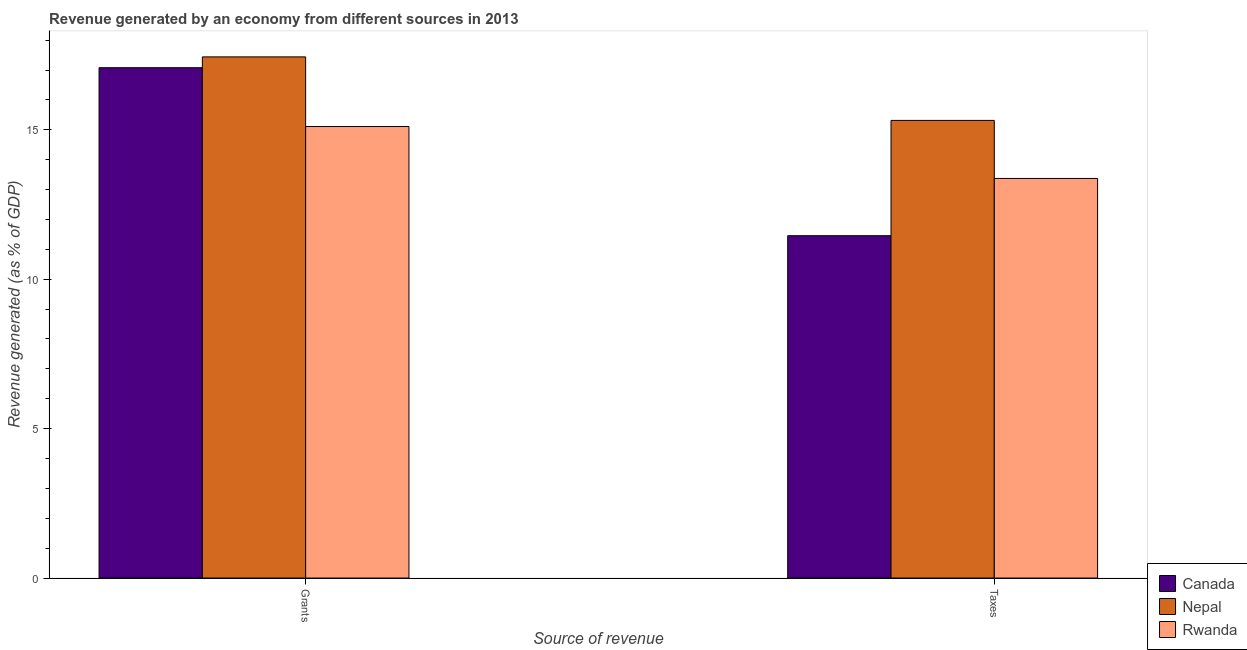How many groups of bars are there?
Ensure brevity in your answer.  2. Are the number of bars on each tick of the X-axis equal?
Keep it short and to the point. Yes. How many bars are there on the 2nd tick from the right?
Make the answer very short. 3. What is the label of the 2nd group of bars from the left?
Provide a short and direct response. Taxes. What is the revenue generated by taxes in Nepal?
Provide a succinct answer. 15.31. Across all countries, what is the maximum revenue generated by taxes?
Your response must be concise. 15.31. Across all countries, what is the minimum revenue generated by grants?
Give a very brief answer. 15.11. In which country was the revenue generated by taxes maximum?
Provide a succinct answer. Nepal. In which country was the revenue generated by grants minimum?
Make the answer very short. Rwanda. What is the total revenue generated by grants in the graph?
Give a very brief answer. 49.63. What is the difference between the revenue generated by taxes in Rwanda and that in Canada?
Ensure brevity in your answer.  1.92. What is the difference between the revenue generated by grants in Canada and the revenue generated by taxes in Rwanda?
Your response must be concise. 3.71. What is the average revenue generated by taxes per country?
Your answer should be very brief. 13.38. What is the difference between the revenue generated by taxes and revenue generated by grants in Nepal?
Keep it short and to the point. -2.13. What is the ratio of the revenue generated by grants in Nepal to that in Canada?
Keep it short and to the point. 1.02. Is the revenue generated by taxes in Rwanda less than that in Nepal?
Your answer should be compact. Yes. What does the 2nd bar from the left in Grants represents?
Make the answer very short. Nepal. What does the 3rd bar from the right in Taxes represents?
Your response must be concise. Canada. What is the difference between two consecutive major ticks on the Y-axis?
Make the answer very short. 5. Are the values on the major ticks of Y-axis written in scientific E-notation?
Make the answer very short. No. Does the graph contain grids?
Offer a very short reply. No. How are the legend labels stacked?
Your answer should be very brief. Vertical. What is the title of the graph?
Provide a succinct answer. Revenue generated by an economy from different sources in 2013. What is the label or title of the X-axis?
Your answer should be very brief. Source of revenue. What is the label or title of the Y-axis?
Your answer should be very brief. Revenue generated (as % of GDP). What is the Revenue generated (as % of GDP) of Canada in Grants?
Ensure brevity in your answer.  17.08. What is the Revenue generated (as % of GDP) of Nepal in Grants?
Give a very brief answer. 17.44. What is the Revenue generated (as % of GDP) in Rwanda in Grants?
Keep it short and to the point. 15.11. What is the Revenue generated (as % of GDP) of Canada in Taxes?
Provide a short and direct response. 11.46. What is the Revenue generated (as % of GDP) in Nepal in Taxes?
Give a very brief answer. 15.31. What is the Revenue generated (as % of GDP) of Rwanda in Taxes?
Ensure brevity in your answer.  13.37. Across all Source of revenue, what is the maximum Revenue generated (as % of GDP) of Canada?
Provide a short and direct response. 17.08. Across all Source of revenue, what is the maximum Revenue generated (as % of GDP) of Nepal?
Your answer should be very brief. 17.44. Across all Source of revenue, what is the maximum Revenue generated (as % of GDP) in Rwanda?
Ensure brevity in your answer.  15.11. Across all Source of revenue, what is the minimum Revenue generated (as % of GDP) in Canada?
Make the answer very short. 11.46. Across all Source of revenue, what is the minimum Revenue generated (as % of GDP) in Nepal?
Ensure brevity in your answer.  15.31. Across all Source of revenue, what is the minimum Revenue generated (as % of GDP) in Rwanda?
Give a very brief answer. 13.37. What is the total Revenue generated (as % of GDP) in Canada in the graph?
Keep it short and to the point. 28.53. What is the total Revenue generated (as % of GDP) of Nepal in the graph?
Make the answer very short. 32.75. What is the total Revenue generated (as % of GDP) in Rwanda in the graph?
Your answer should be very brief. 28.48. What is the difference between the Revenue generated (as % of GDP) in Canada in Grants and that in Taxes?
Offer a very short reply. 5.62. What is the difference between the Revenue generated (as % of GDP) of Nepal in Grants and that in Taxes?
Ensure brevity in your answer.  2.13. What is the difference between the Revenue generated (as % of GDP) in Rwanda in Grants and that in Taxes?
Your answer should be compact. 1.74. What is the difference between the Revenue generated (as % of GDP) in Canada in Grants and the Revenue generated (as % of GDP) in Nepal in Taxes?
Ensure brevity in your answer.  1.76. What is the difference between the Revenue generated (as % of GDP) in Canada in Grants and the Revenue generated (as % of GDP) in Rwanda in Taxes?
Keep it short and to the point. 3.71. What is the difference between the Revenue generated (as % of GDP) in Nepal in Grants and the Revenue generated (as % of GDP) in Rwanda in Taxes?
Offer a terse response. 4.07. What is the average Revenue generated (as % of GDP) of Canada per Source of revenue?
Your answer should be compact. 14.27. What is the average Revenue generated (as % of GDP) in Nepal per Source of revenue?
Make the answer very short. 16.38. What is the average Revenue generated (as % of GDP) in Rwanda per Source of revenue?
Your answer should be compact. 14.24. What is the difference between the Revenue generated (as % of GDP) of Canada and Revenue generated (as % of GDP) of Nepal in Grants?
Your response must be concise. -0.36. What is the difference between the Revenue generated (as % of GDP) in Canada and Revenue generated (as % of GDP) in Rwanda in Grants?
Provide a succinct answer. 1.97. What is the difference between the Revenue generated (as % of GDP) in Nepal and Revenue generated (as % of GDP) in Rwanda in Grants?
Keep it short and to the point. 2.33. What is the difference between the Revenue generated (as % of GDP) of Canada and Revenue generated (as % of GDP) of Nepal in Taxes?
Provide a succinct answer. -3.86. What is the difference between the Revenue generated (as % of GDP) of Canada and Revenue generated (as % of GDP) of Rwanda in Taxes?
Your answer should be compact. -1.92. What is the difference between the Revenue generated (as % of GDP) in Nepal and Revenue generated (as % of GDP) in Rwanda in Taxes?
Make the answer very short. 1.94. What is the ratio of the Revenue generated (as % of GDP) in Canada in Grants to that in Taxes?
Give a very brief answer. 1.49. What is the ratio of the Revenue generated (as % of GDP) in Nepal in Grants to that in Taxes?
Offer a terse response. 1.14. What is the ratio of the Revenue generated (as % of GDP) of Rwanda in Grants to that in Taxes?
Provide a succinct answer. 1.13. What is the difference between the highest and the second highest Revenue generated (as % of GDP) in Canada?
Give a very brief answer. 5.62. What is the difference between the highest and the second highest Revenue generated (as % of GDP) of Nepal?
Offer a terse response. 2.13. What is the difference between the highest and the second highest Revenue generated (as % of GDP) of Rwanda?
Provide a succinct answer. 1.74. What is the difference between the highest and the lowest Revenue generated (as % of GDP) in Canada?
Give a very brief answer. 5.62. What is the difference between the highest and the lowest Revenue generated (as % of GDP) of Nepal?
Offer a terse response. 2.13. What is the difference between the highest and the lowest Revenue generated (as % of GDP) in Rwanda?
Give a very brief answer. 1.74. 